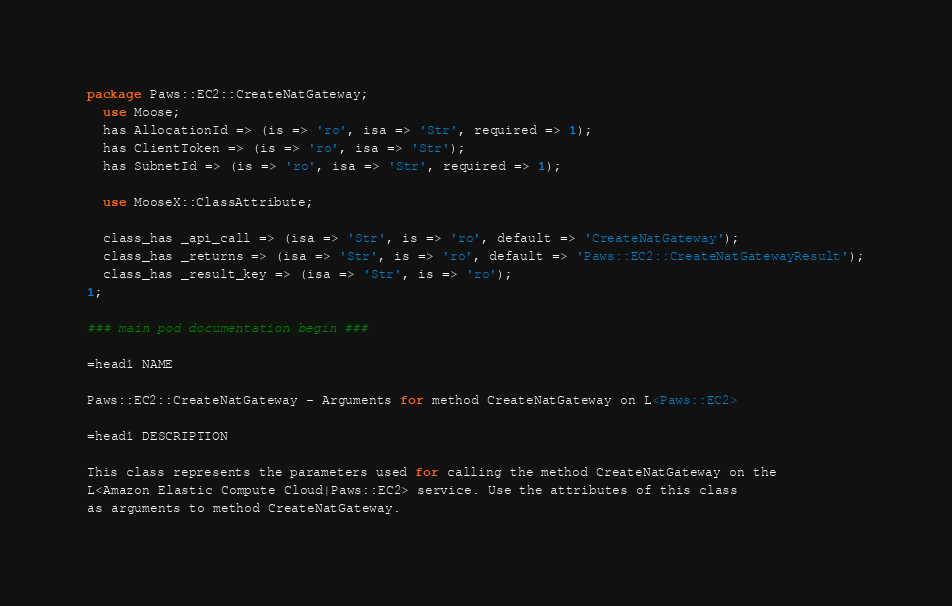<code> <loc_0><loc_0><loc_500><loc_500><_Perl_>
package Paws::EC2::CreateNatGateway;
  use Moose;
  has AllocationId => (is => 'ro', isa => 'Str', required => 1);
  has ClientToken => (is => 'ro', isa => 'Str');
  has SubnetId => (is => 'ro', isa => 'Str', required => 1);

  use MooseX::ClassAttribute;

  class_has _api_call => (isa => 'Str', is => 'ro', default => 'CreateNatGateway');
  class_has _returns => (isa => 'Str', is => 'ro', default => 'Paws::EC2::CreateNatGatewayResult');
  class_has _result_key => (isa => 'Str', is => 'ro');
1;

### main pod documentation begin ###

=head1 NAME

Paws::EC2::CreateNatGateway - Arguments for method CreateNatGateway on L<Paws::EC2>

=head1 DESCRIPTION

This class represents the parameters used for calling the method CreateNatGateway on the
L<Amazon Elastic Compute Cloud|Paws::EC2> service. Use the attributes of this class
as arguments to method CreateNatGateway.
</code> 